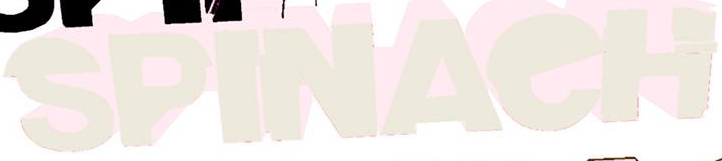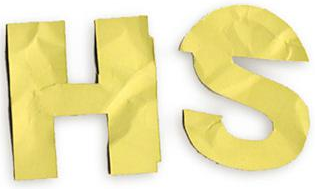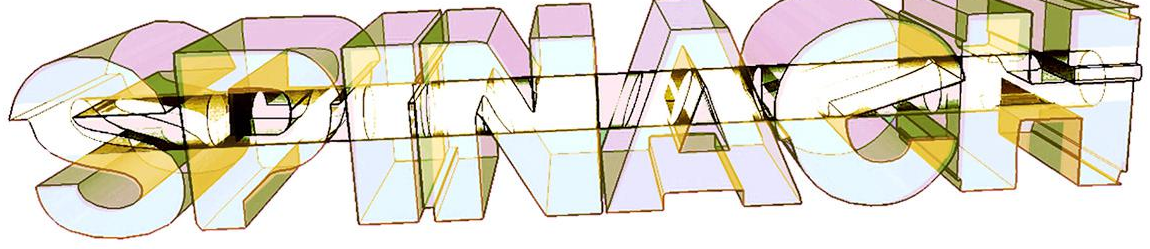What text appears in these images from left to right, separated by a semicolon? SPINAeH; HS; SPINAeH 